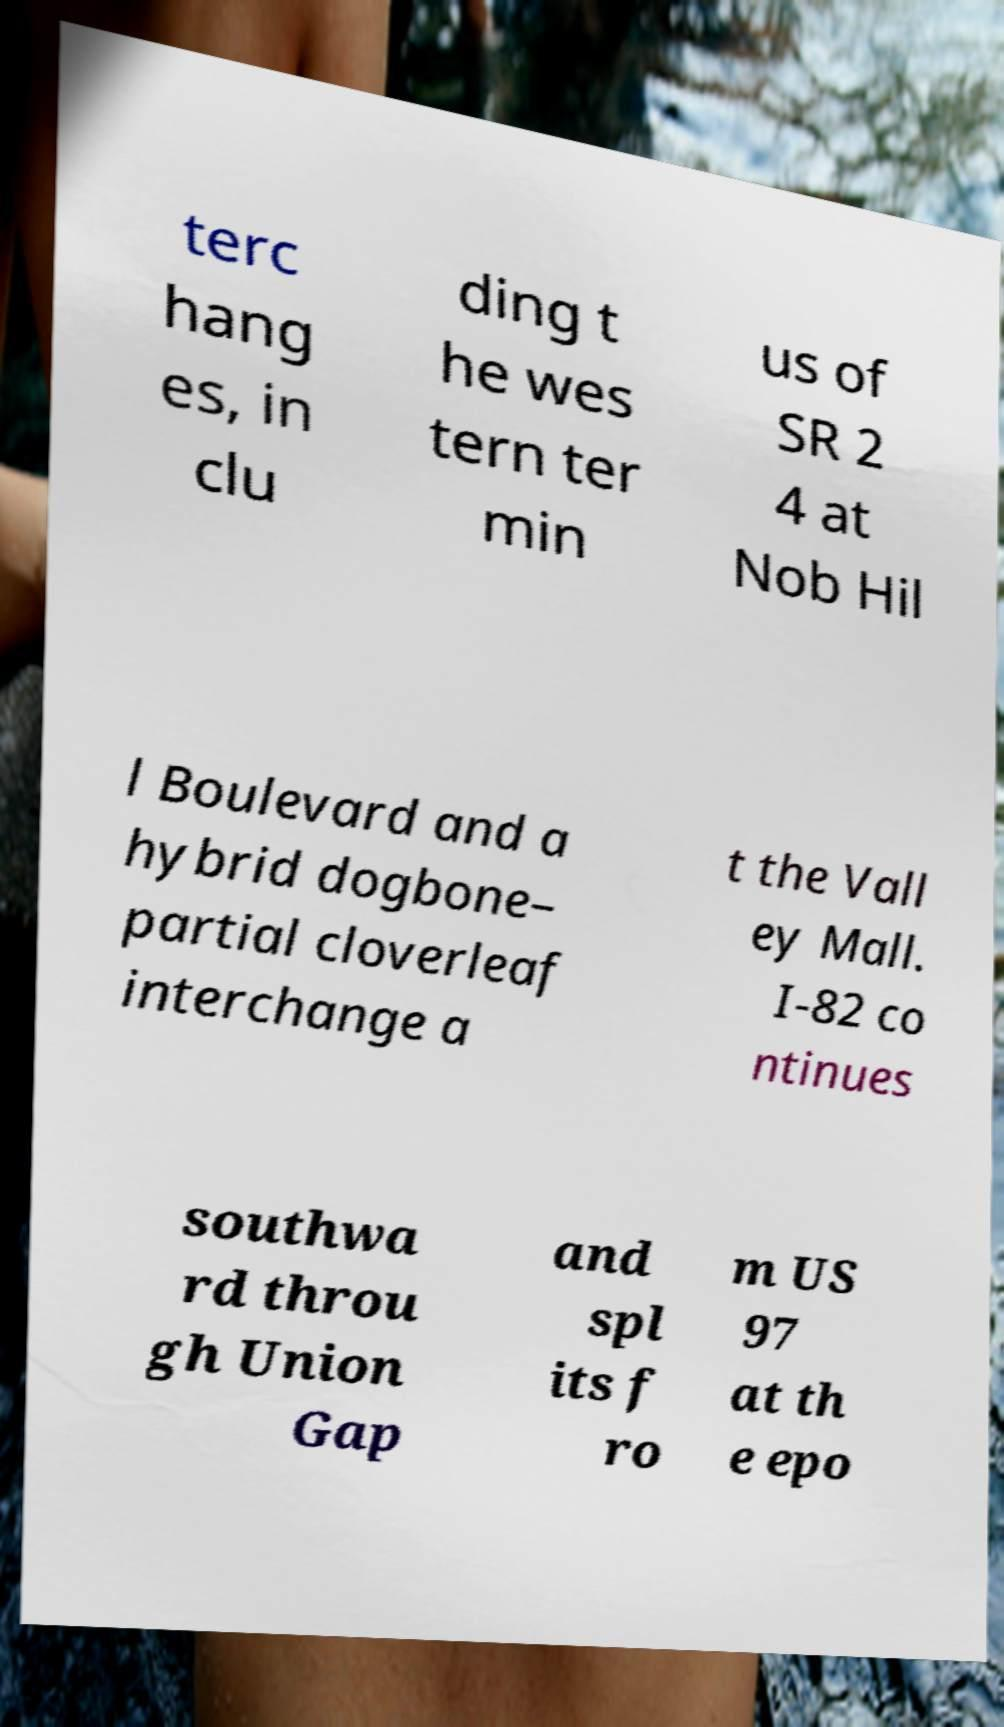Please identify and transcribe the text found in this image. terc hang es, in clu ding t he wes tern ter min us of SR 2 4 at Nob Hil l Boulevard and a hybrid dogbone– partial cloverleaf interchange a t the Vall ey Mall. I-82 co ntinues southwa rd throu gh Union Gap and spl its f ro m US 97 at th e epo 